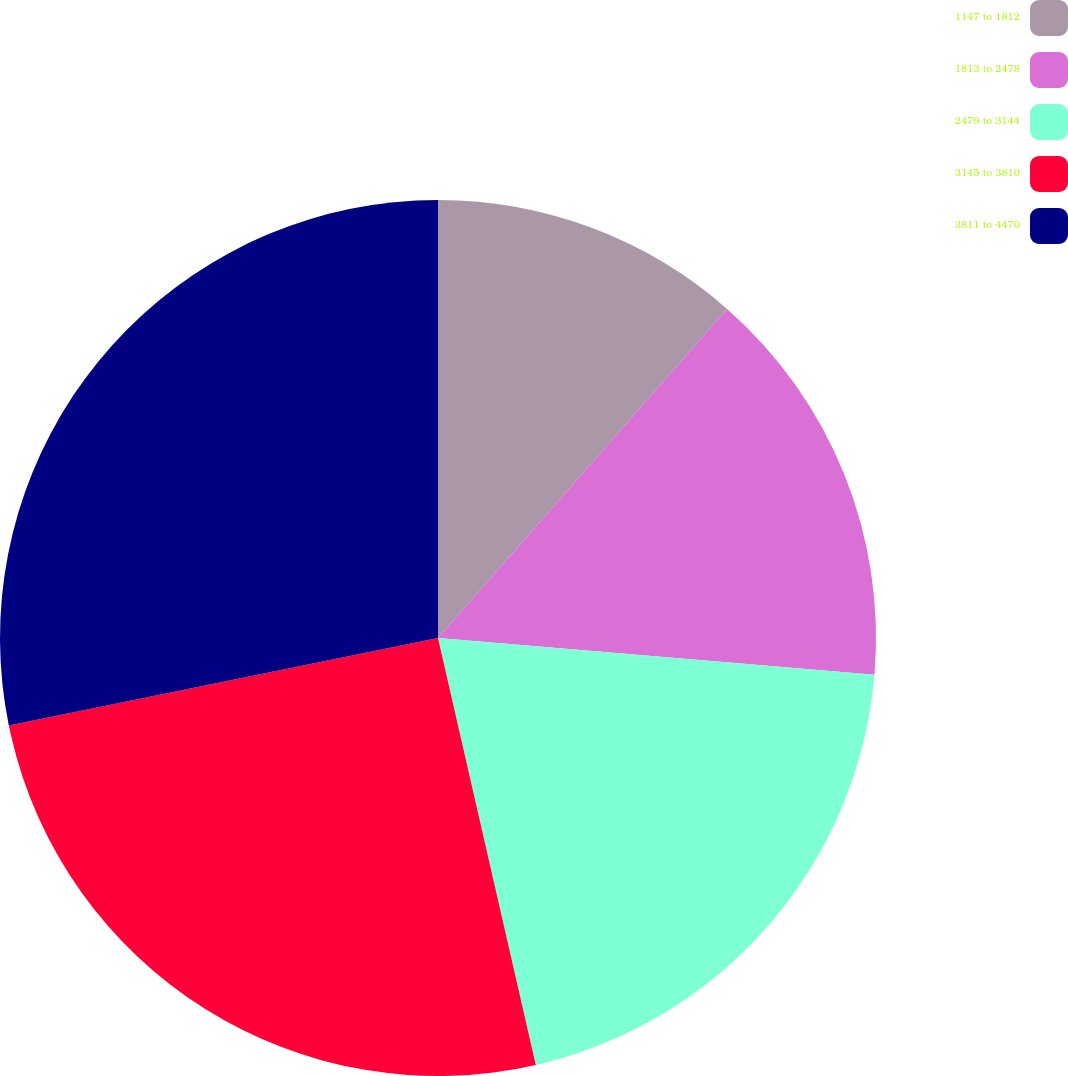<chart> <loc_0><loc_0><loc_500><loc_500><pie_chart><fcel>1147 to 1812<fcel>1813 to 2478<fcel>2479 to 3144<fcel>3145 to 3810<fcel>3811 to 4470<nl><fcel>11.47%<fcel>14.87%<fcel>20.08%<fcel>25.39%<fcel>28.2%<nl></chart> 